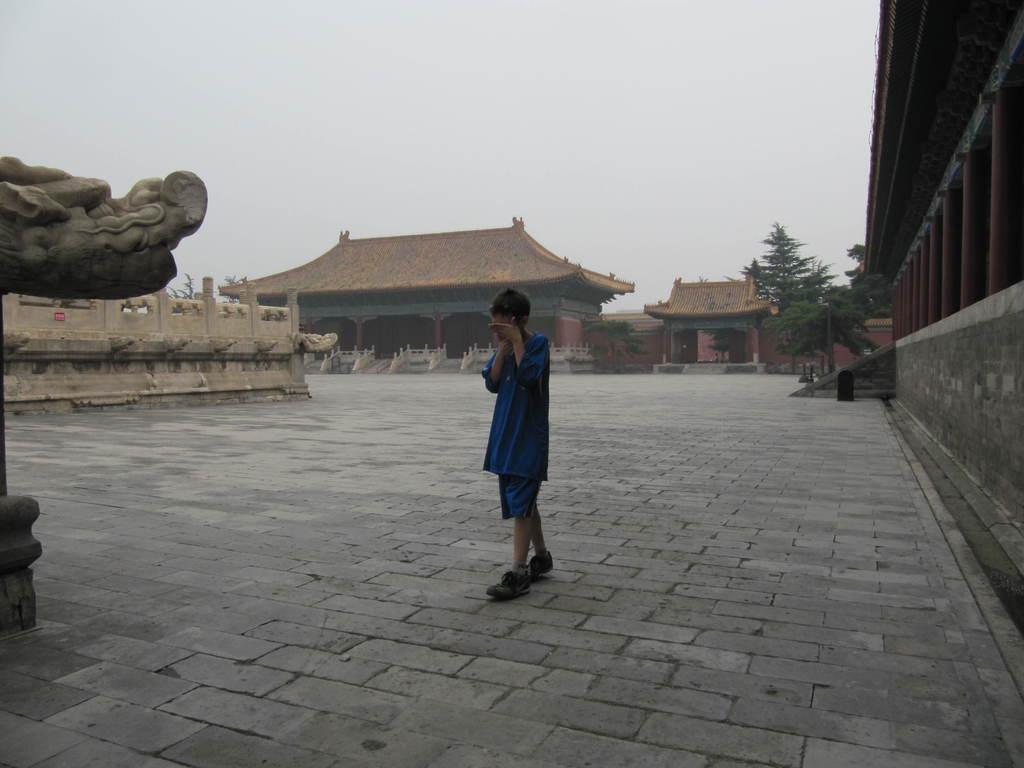Please provide a concise description of this image. This image is taken outdoors. At the top of the image there is the sky. At the bottom of the image there is a floor. In the middle of the image a boy is walking on the floor. In the background there are few Chinese architectures with walls, buildings, roofs and doors. There are a few stairs. On the left side of the image there is a sculpture. On the right side of the image there is a house and there are a few trees. 